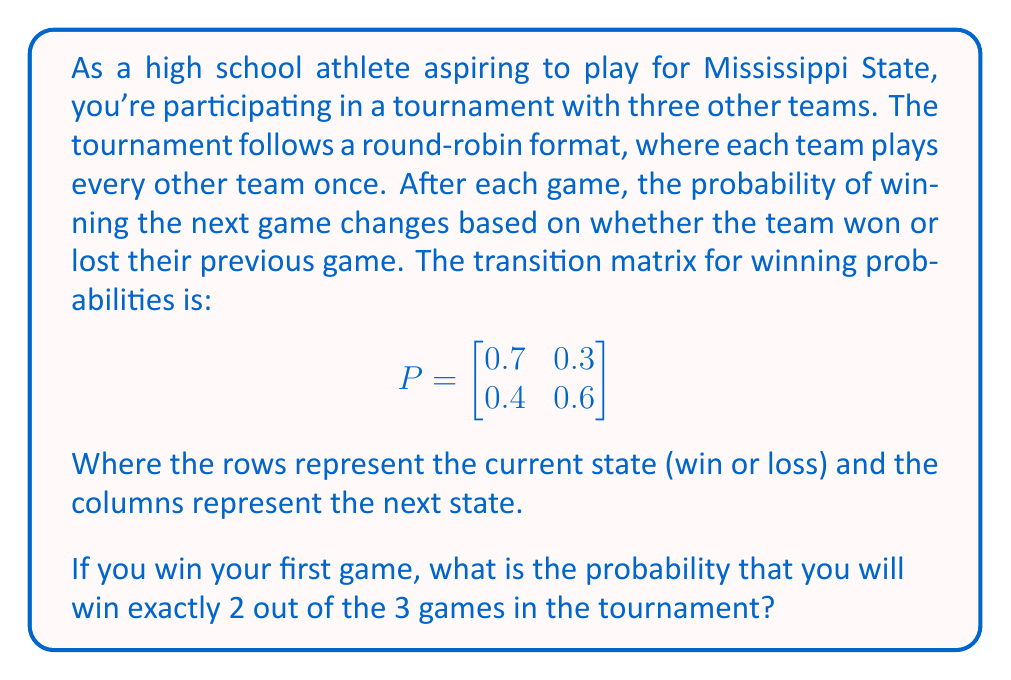What is the answer to this math problem? Let's approach this step-by-step:

1) We need to find the probability of winning 2 out of 3 games, given that we won the first game.

2) After winning the first game, we need to win 1 and lose 1 of the next 2 games. This can happen in two ways:
   - Win 2nd game, Lose 3rd game
   - Lose 2nd game, Win 3rd game

3) Let's calculate the probability of each scenario:

   Scenario 1: Win, Win, Lose
   P(Win 2nd | Won 1st) = 0.7 (from the transition matrix)
   P(Lose 3rd | Won 2nd) = 0.3
   P(Win, Win, Lose) = 0.7 * 0.3 = 0.21

   Scenario 2: Win, Lose, Win
   P(Lose 2nd | Won 1st) = 0.3
   P(Win 3rd | Lost 2nd) = 0.4
   P(Win, Lose, Win) = 0.3 * 0.4 = 0.12

4) The total probability is the sum of these two scenarios:
   P(Win exactly 2 out of 3) = 0.21 + 0.12 = 0.33

Therefore, the probability of winning exactly 2 out of 3 games, given that you won the first game, is 0.33 or 33%.
Answer: 0.33 